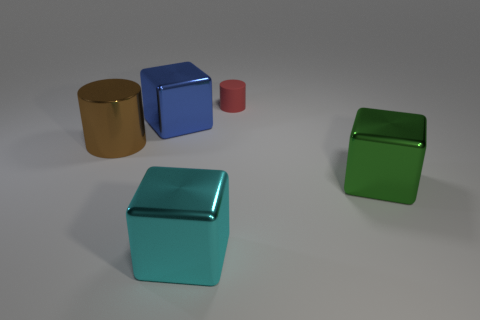What number of other objects have the same material as the big cyan thing?
Offer a terse response. 3. The cylinder that is the same material as the green cube is what color?
Give a very brief answer. Brown. Is the shape of the green shiny object the same as the big blue shiny object?
Offer a very short reply. Yes. Are there any green things that are to the left of the big thing left of the large metallic block that is behind the large green block?
Provide a succinct answer. No. How many other tiny matte things are the same color as the rubber object?
Ensure brevity in your answer.  0. What shape is the blue object that is the same size as the brown thing?
Provide a short and direct response. Cube. Are there any shiny objects in front of the big blue cube?
Give a very brief answer. Yes. Do the red cylinder and the cyan object have the same size?
Provide a succinct answer. No. What is the shape of the big metal thing that is on the right side of the small rubber object?
Your answer should be compact. Cube. Are there any other objects that have the same size as the rubber thing?
Your response must be concise. No. 